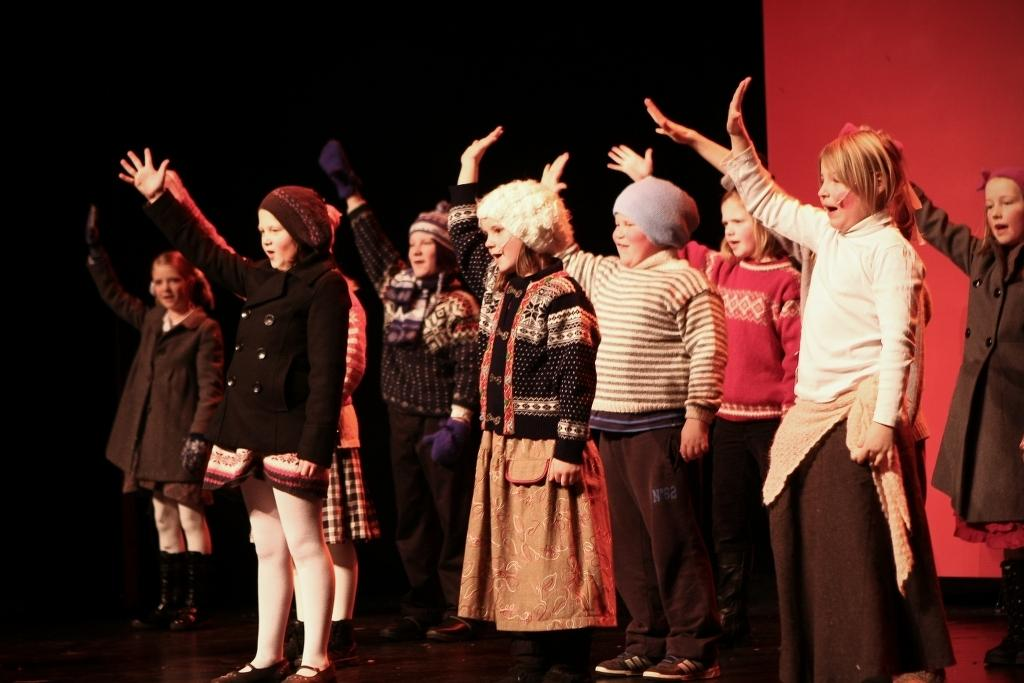What is the main subject of the image? The main subject of the image is a group of kids. What are the kids doing in the image? The kids are standing and raising their hands in the image. Can you describe the expressions on the kids' faces? Some of the kids are smiling in the image. What colors can be seen in the background of the image? The background of the image includes black and red colors. What type of minister is standing next to the kids in the image? There is no minister present in the image; it only features a group of kids. Can you tell me how many spots are visible on the kids' clothing in the image? There is no mention of spots on the kids' clothing in the image. 